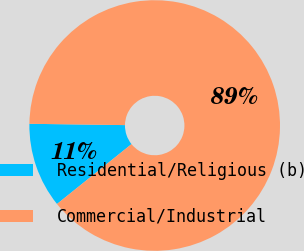Convert chart. <chart><loc_0><loc_0><loc_500><loc_500><pie_chart><fcel>Residential/Religious (b)<fcel>Commercial/Industrial<nl><fcel>10.99%<fcel>89.01%<nl></chart> 